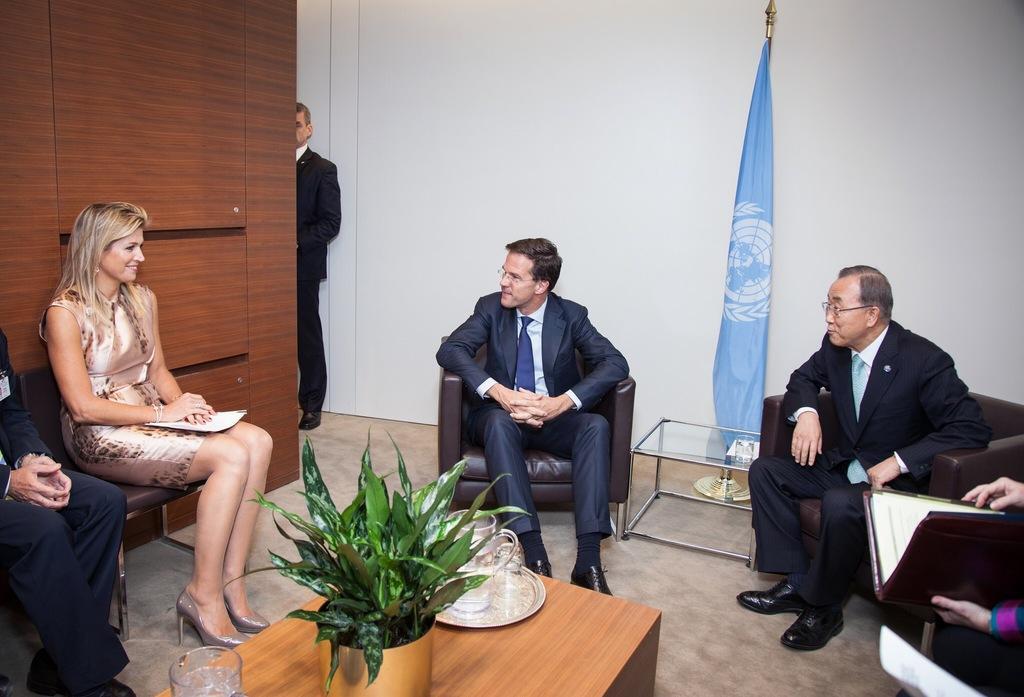How would you summarize this image in a sentence or two? This picture is clicked inside the room and we can see the group of people wearing suits and sitting on the couches. On the left, we can see a woman wearing dress, holding some object, smiling and sitting on the chair. In the center we can see a center table on the top of which a potted plant and some other items are placed. In the background, we can see the wall, flag, table and a person wearing black color dress and seems to be standing on the ground and we can see some other items. In the right corner we can see another person holding a book and seems to be standing. 